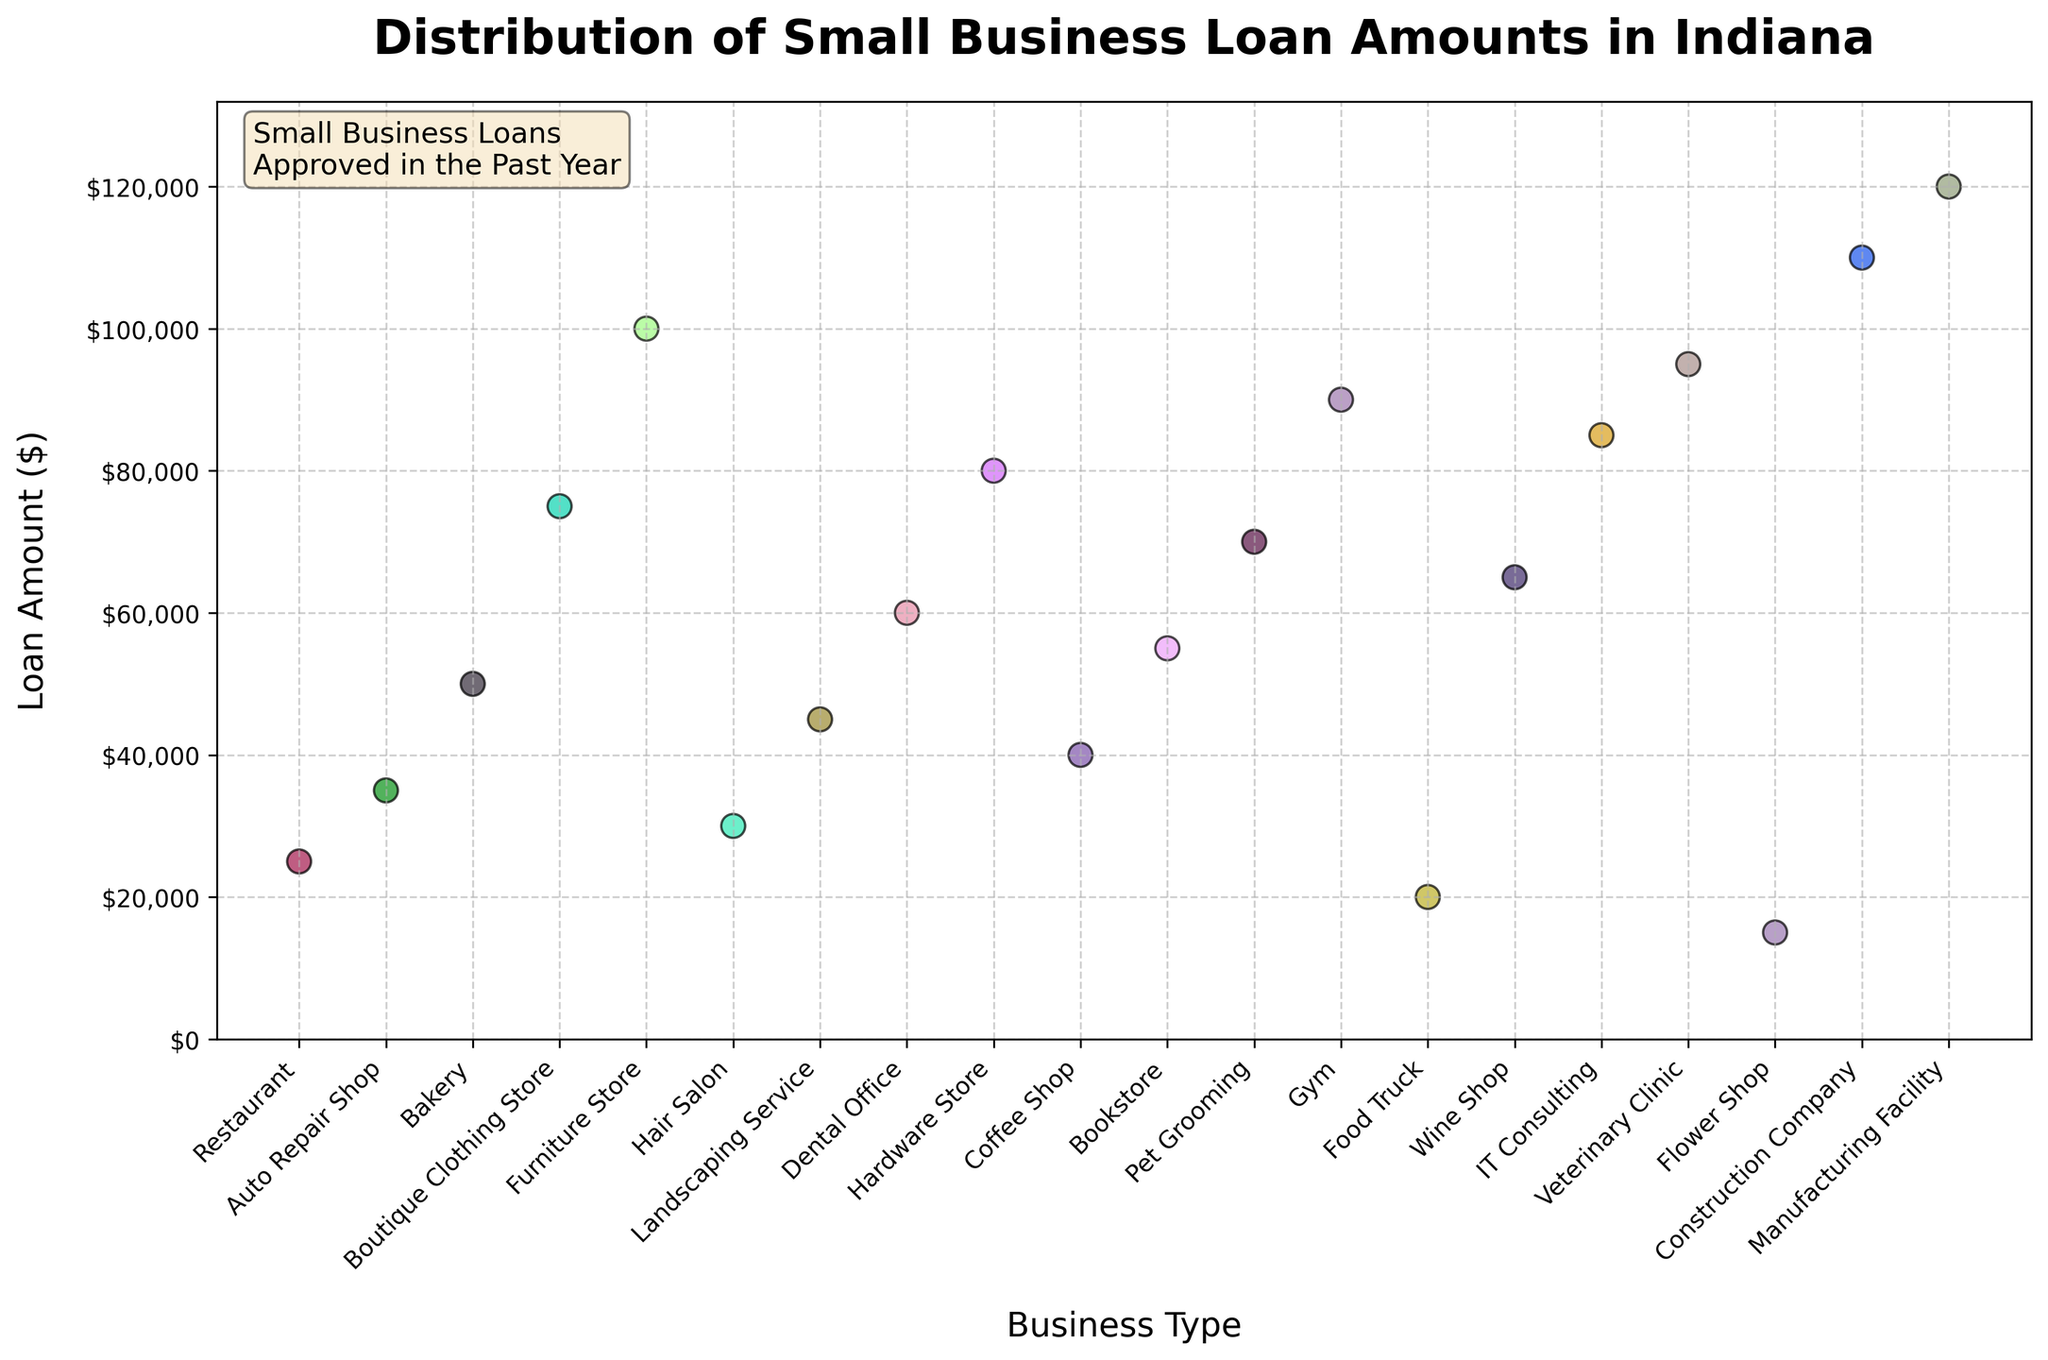What is the title of the strip plot? The title is prominently displayed at the top of the plot. It provides an immediate context for understanding what the plot represents.
Answer: Distribution of Small Business Loan Amounts in Indiana Which business type received the largest loan amount? By looking at the y-axis values, the largest loan amount is at the highest point on the plot. The corresponding business type aligned with this value on the x-axis is what we identify.
Answer: Manufacturing Facility What is the range of the loan amounts shown in the plot? To find the range, we identify the smallest and largest loan amounts on the y-axis. The smallest loan amount is $15,000, and the largest is $120,000. The range is calculated as the difference between these two values.
Answer: $105,000 Which two business types received loans close to $50,000? To answer this, we look for data points around the $50,000 mark on the y-axis and identify the corresponding business types on the x-axis.
Answer: Bakery and Landscaping Service Does any business type appear more than once in the plot? We need to look at the x-axis labels and check for any repetitions of the same business type. Each business type appears only once in this data.
Answer: No How many business types received loan amounts above $80,000? We identify all data points above the $80,000 mark on the y-axis and count the corresponding business types.
Answer: 6 business types What is the average loan amount received by the businesses? To find the average loan amount, sum up all the loan amounts and divide by the number of data points. Sum: 25000 + 35000 + 50000 + 75000 + 100000 + 30000 + 45000 + 60000 + 80000 + 40000 + 55000 + 70000 + 90000 + 20000 + 65000 + 85000 + 95000 + 15000 + 110000 + 120000 = 1,160,000. Number of data points: 20. Average = 1,160,000 / 20
Answer: $58,000 Which business type received the smallest loan amount, and how much was it? By identifying the lowest point on the y-axis and noting the corresponding business type on the x-axis, we can determine the answer.
Answer: Flower Shop, $15,000 Are there more loan amounts above or below $50,000? We count the number of data points above and below the $50,000 mark respectively and compare them.
Answer: Above Which loan amount is closest to the median value in this data? First, sort all loan amounts to find the median value, which is the middle value in the sorted list. Sorted list: 15000, 20000, 25000, 30000, 35000, 40000, 45000, 50000, 55000, 60000, 65000, 70000, 75000, 80000, 85000, 90000, 95000, 100000, 110000, 120000. Since there are 20 values, the median would be the average of the 10th and 11th values: (60000 + 65000) / 2 = 62,500. The loan amount closest to this is $60,000.
Answer: $60,000 